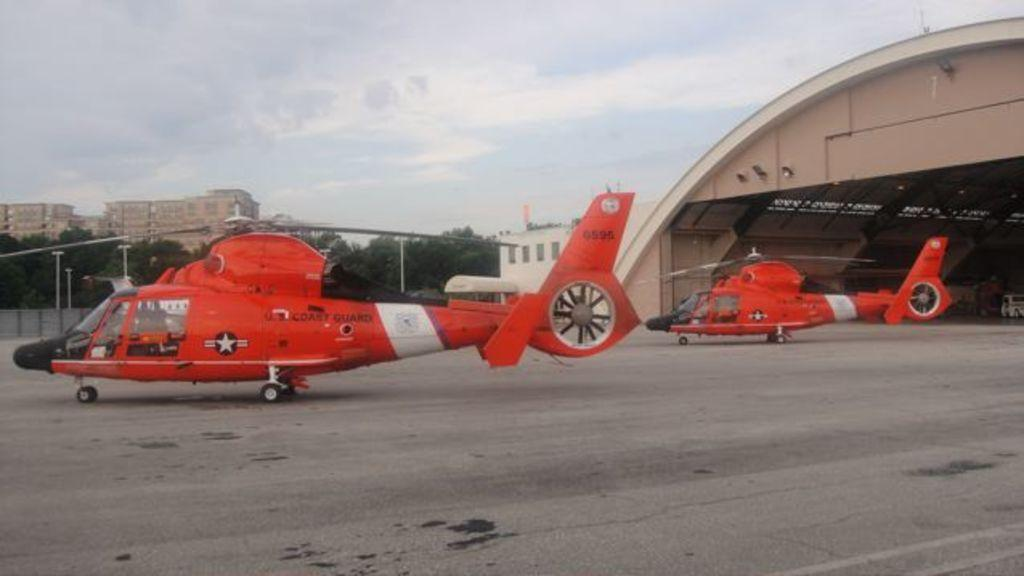What can be seen on the road in the image? There are planes on the road in the image. What structures are present in the image besides the planes? There are poles, trees, and buildings in the image. What is visible in the background of the image? The sky is visible in the background of the image. What can be observed in the sky? Clouds are present in the sky. Where is the shelf located in the image? There is no shelf present in the image. What type of coal can be seen in the image? There is no coal present in the image. 